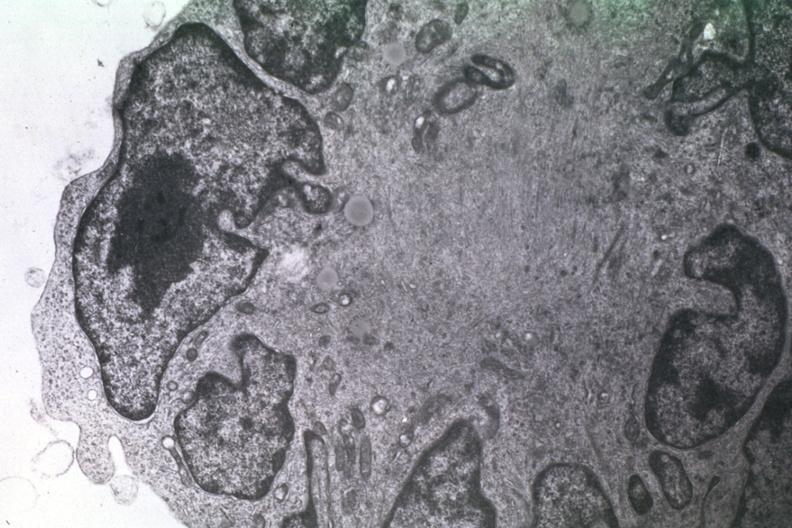what is present?
Answer the question using a single word or phrase. Papillary astrocytoma 